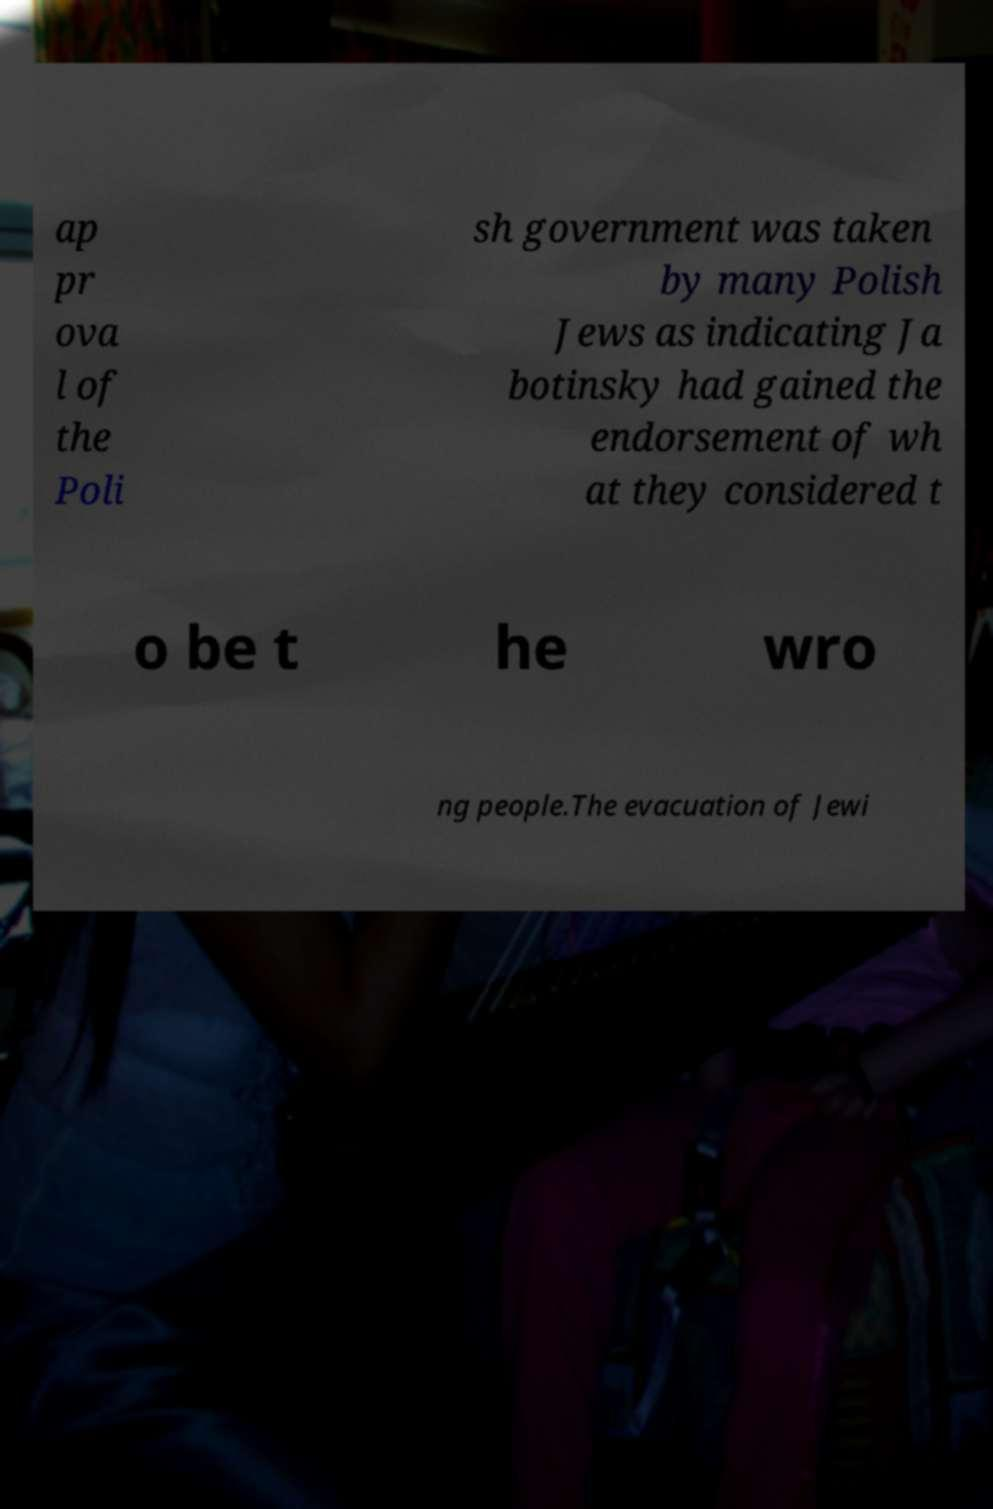Please read and relay the text visible in this image. What does it say? ap pr ova l of the Poli sh government was taken by many Polish Jews as indicating Ja botinsky had gained the endorsement of wh at they considered t o be t he wro ng people.The evacuation of Jewi 